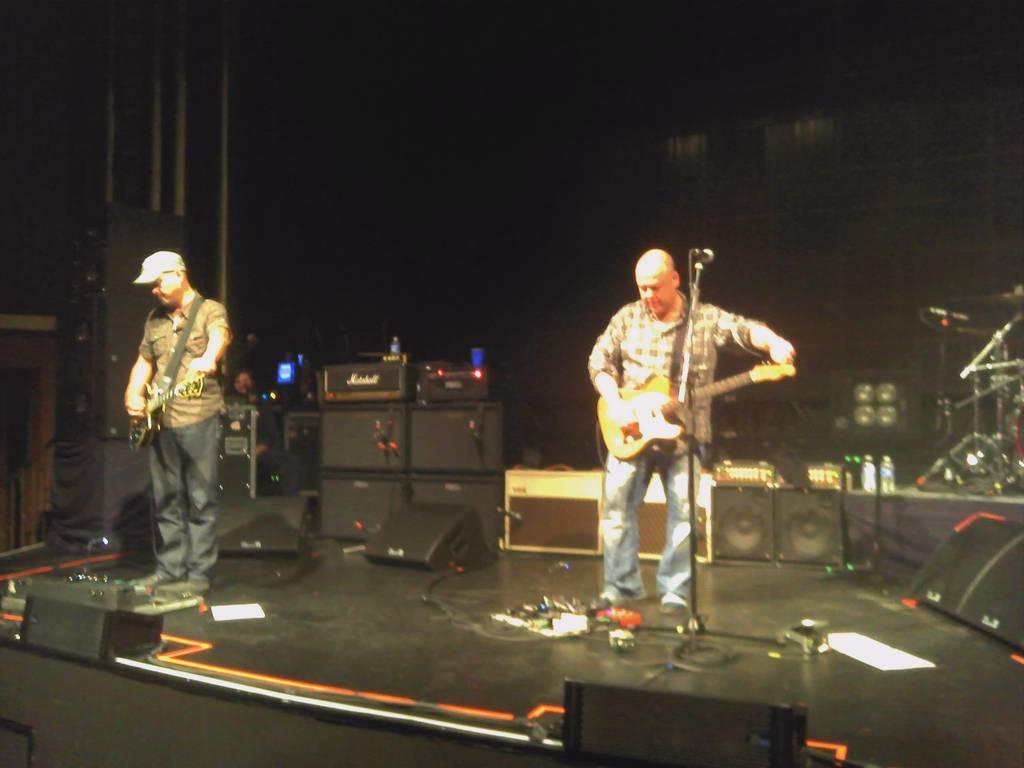Can you describe this image briefly? In this image on the right there is a man he wear check shirt, trouser he is playing guitar. On the left there is a man he wear cap,shirt and trouser. This is a stage. In the background there are many speakers,screen and bottles. 